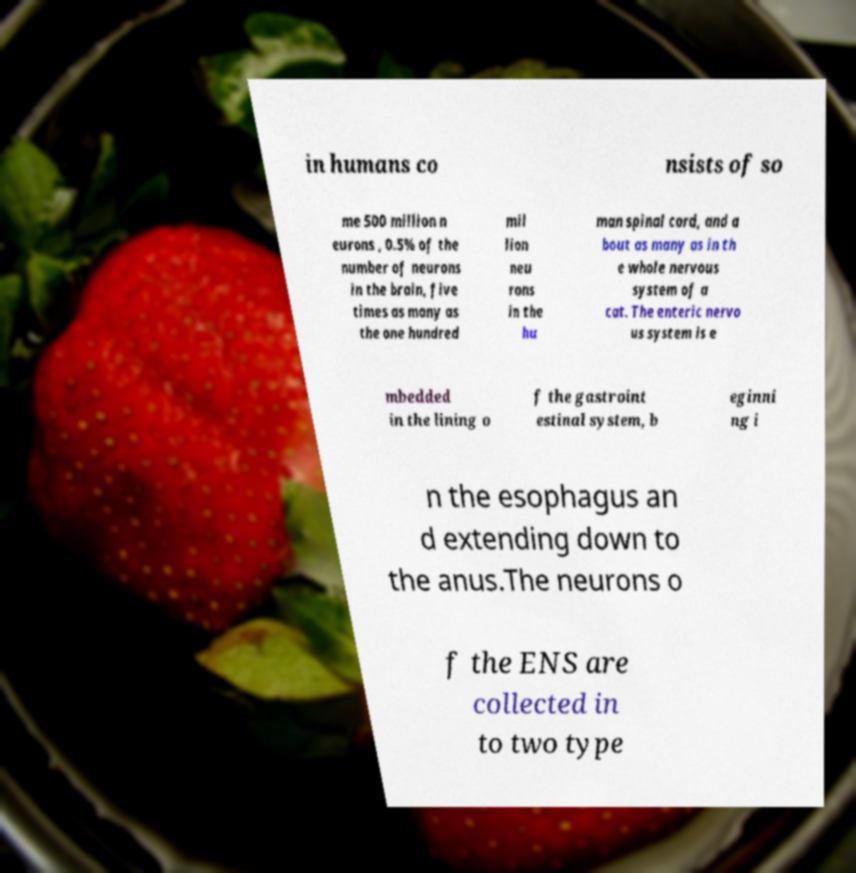Could you extract and type out the text from this image? in humans co nsists of so me 500 million n eurons , 0.5% of the number of neurons in the brain, five times as many as the one hundred mil lion neu rons in the hu man spinal cord, and a bout as many as in th e whole nervous system of a cat. The enteric nervo us system is e mbedded in the lining o f the gastroint estinal system, b eginni ng i n the esophagus an d extending down to the anus.The neurons o f the ENS are collected in to two type 